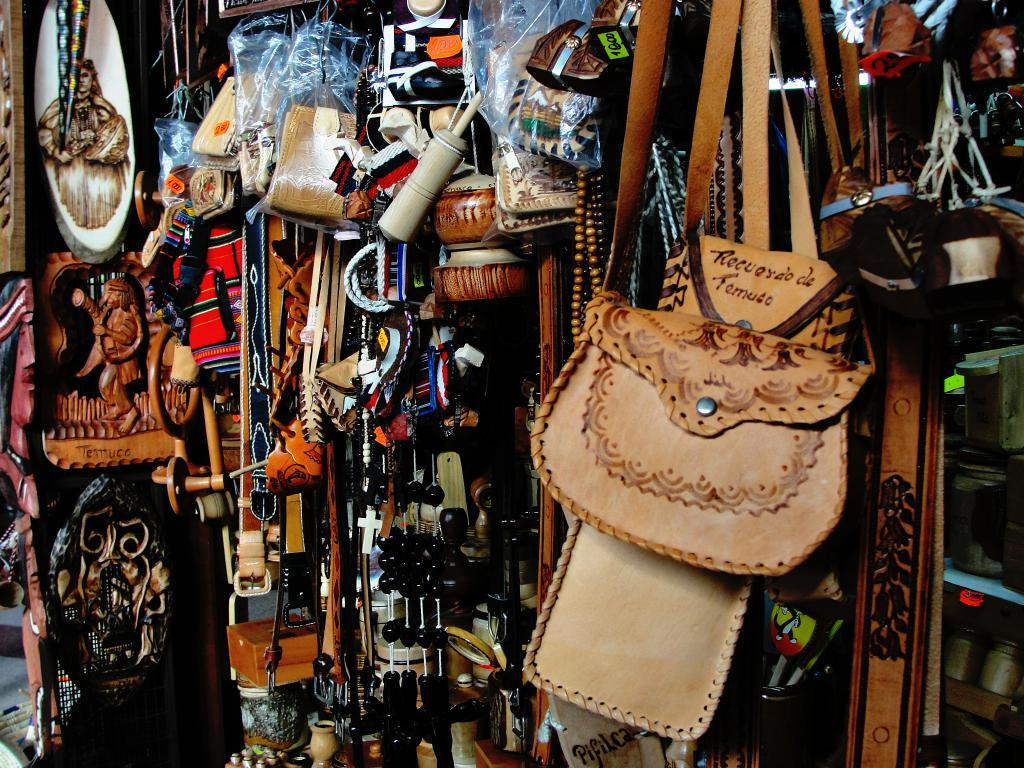What types of items are in the foreground of the image? In the foreground of the image, there are sling bags, belts, hangings, pots, wall hanging sculptures, and bags. Can you describe the specific items that are visible? The sling bags, belts, and bags are all types of accessories, while the hangings, pots, and wall hanging sculptures are decorative items. How many different types of items are present in the foreground? There are six different types of items present in the foreground. What type of coastline can be seen in the image? There is no coastline present in the image; it features various items in the foreground. What selection of notebooks is visible in the image? There are no notebooks visible in the image. 